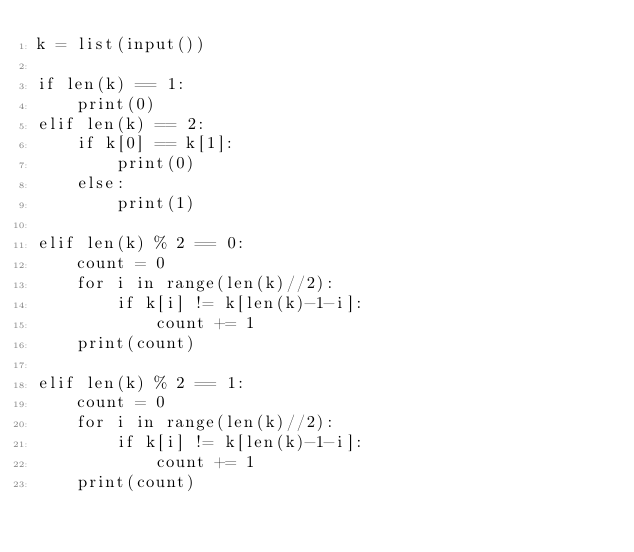Convert code to text. <code><loc_0><loc_0><loc_500><loc_500><_Python_>k = list(input())

if len(k) == 1:
    print(0)
elif len(k) == 2:
    if k[0] == k[1]:
        print(0)
    else:
        print(1)

elif len(k) % 2 == 0:
    count = 0
    for i in range(len(k)//2):
        if k[i] != k[len(k)-1-i]:
            count += 1
    print(count)

elif len(k) % 2 == 1:
    count = 0
    for i in range(len(k)//2):
        if k[i] != k[len(k)-1-i]:
            count += 1
    print(count)
</code> 